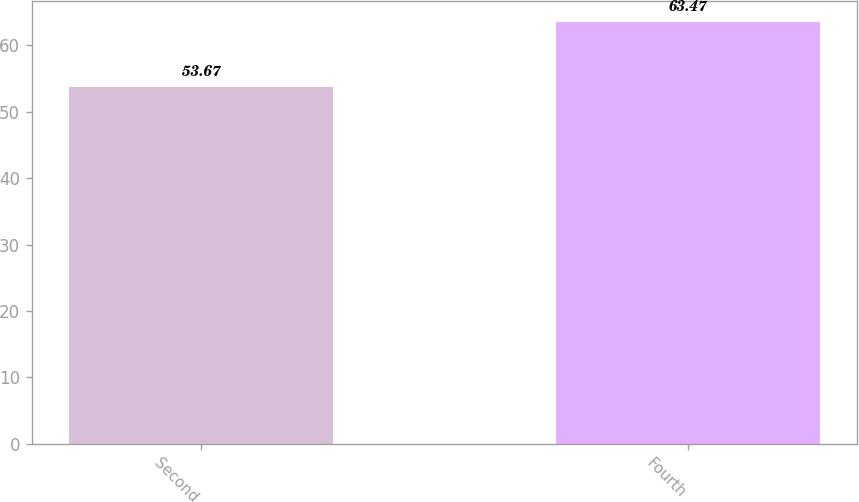<chart> <loc_0><loc_0><loc_500><loc_500><bar_chart><fcel>Second<fcel>Fourth<nl><fcel>53.67<fcel>63.47<nl></chart> 